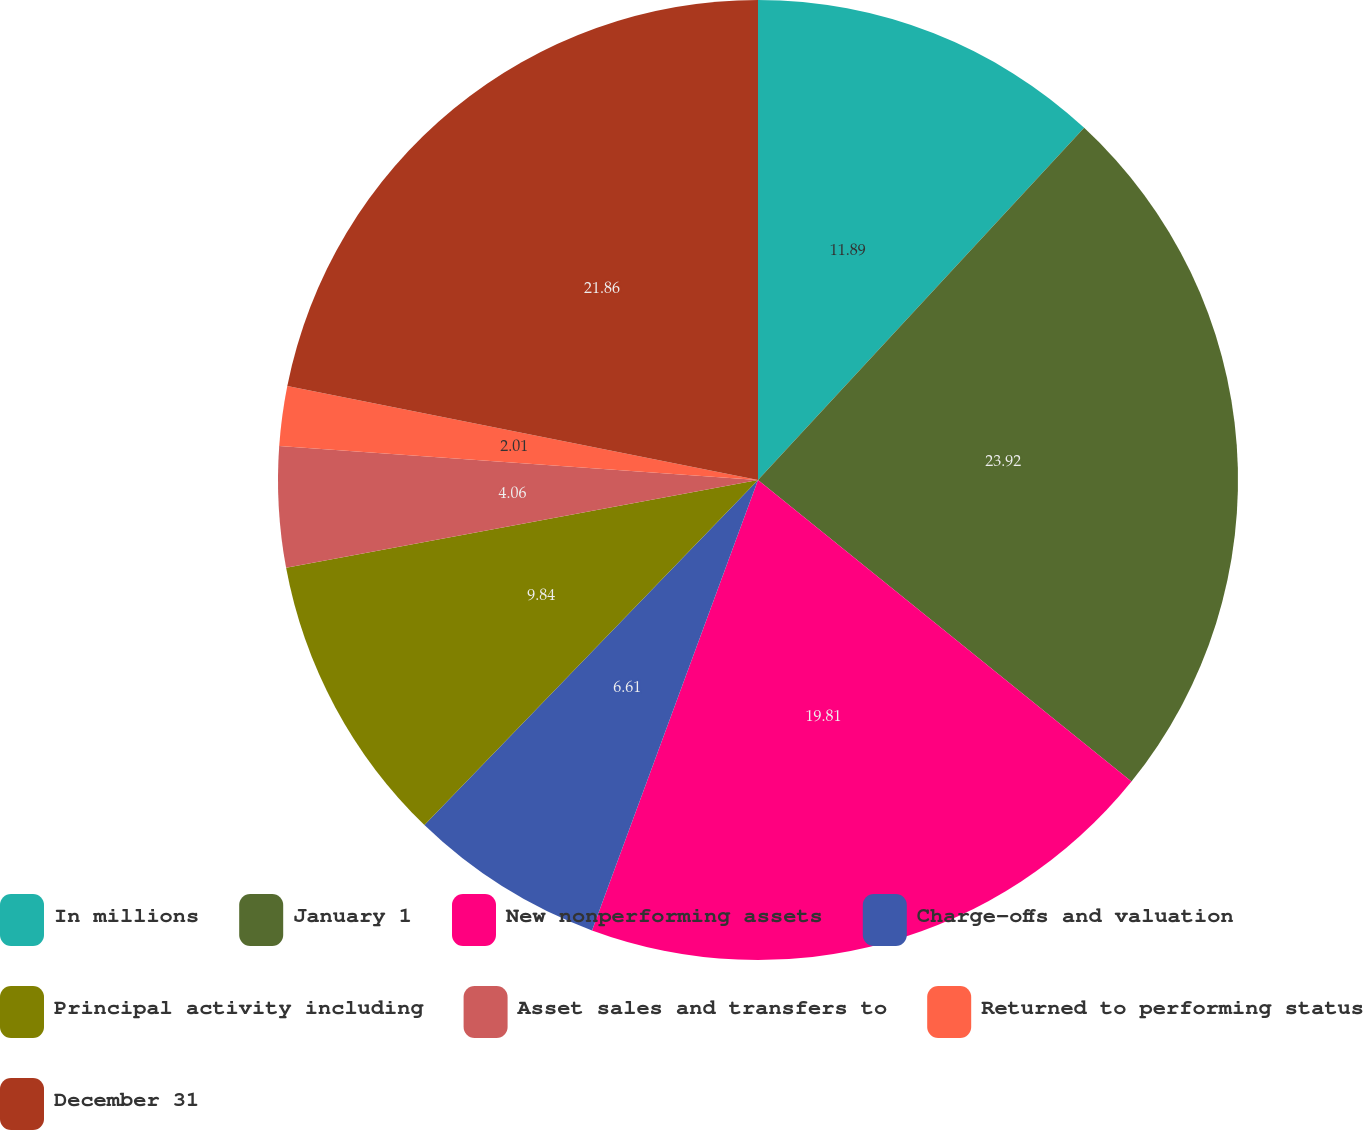Convert chart to OTSL. <chart><loc_0><loc_0><loc_500><loc_500><pie_chart><fcel>In millions<fcel>January 1<fcel>New nonperforming assets<fcel>Charge-offs and valuation<fcel>Principal activity including<fcel>Asset sales and transfers to<fcel>Returned to performing status<fcel>December 31<nl><fcel>11.89%<fcel>23.92%<fcel>19.81%<fcel>6.61%<fcel>9.84%<fcel>4.06%<fcel>2.01%<fcel>21.86%<nl></chart> 